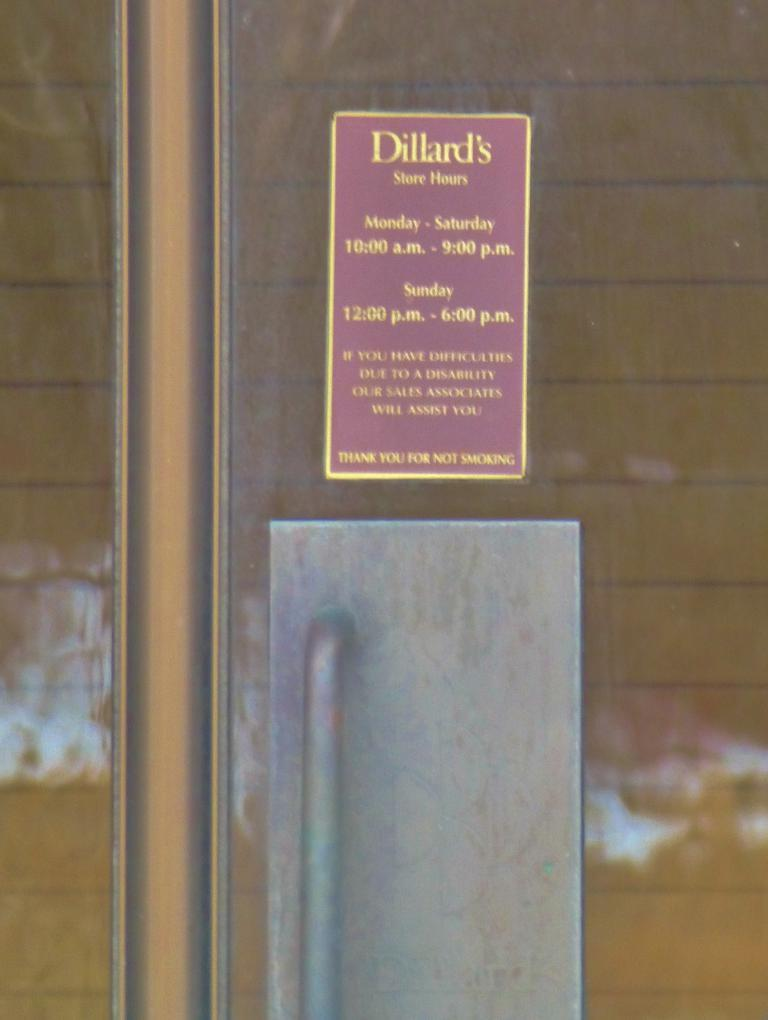What type of object is present in the image that allows for entry or exit? There is a door in the image that allows for entry or exit. What feature is present on the door to facilitate its use? The door has a handle. What can be seen on the wall in the image? There is a poster with text on it in the image. What type of surface is visible in the image? There is a wall visible in the image. How many cats can be seen sleeping on the tooth in the image? There are no cats or teeth present in the image. 